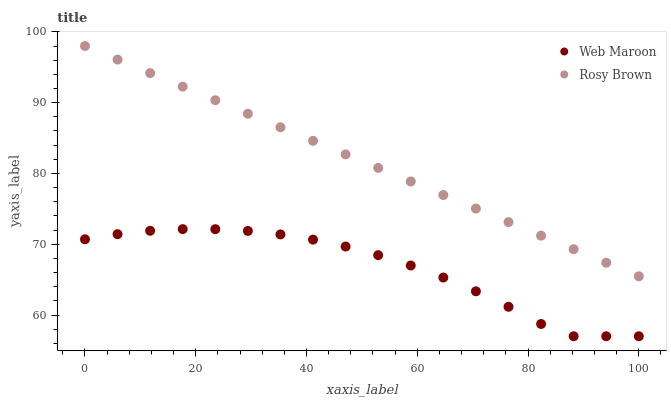Does Web Maroon have the minimum area under the curve?
Answer yes or no. Yes. Does Rosy Brown have the maximum area under the curve?
Answer yes or no. Yes. Does Web Maroon have the maximum area under the curve?
Answer yes or no. No. Is Rosy Brown the smoothest?
Answer yes or no. Yes. Is Web Maroon the roughest?
Answer yes or no. Yes. Is Web Maroon the smoothest?
Answer yes or no. No. Does Web Maroon have the lowest value?
Answer yes or no. Yes. Does Rosy Brown have the highest value?
Answer yes or no. Yes. Does Web Maroon have the highest value?
Answer yes or no. No. Is Web Maroon less than Rosy Brown?
Answer yes or no. Yes. Is Rosy Brown greater than Web Maroon?
Answer yes or no. Yes. Does Web Maroon intersect Rosy Brown?
Answer yes or no. No. 